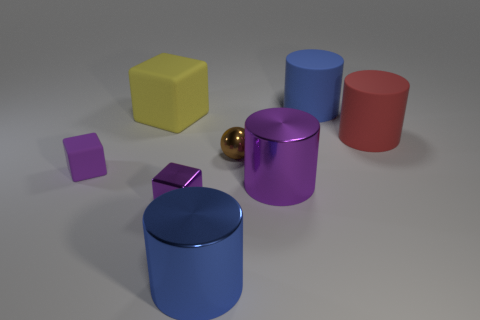Subtract all matte cubes. How many cubes are left? 1 Subtract all purple cubes. How many cubes are left? 1 Subtract all blocks. How many objects are left? 5 Add 1 purple rubber blocks. How many objects exist? 9 Subtract 3 cylinders. How many cylinders are left? 1 Subtract all blue cylinders. How many green balls are left? 0 Subtract all red things. Subtract all large blocks. How many objects are left? 6 Add 3 small purple shiny objects. How many small purple shiny objects are left? 4 Add 3 small spheres. How many small spheres exist? 4 Subtract 1 brown spheres. How many objects are left? 7 